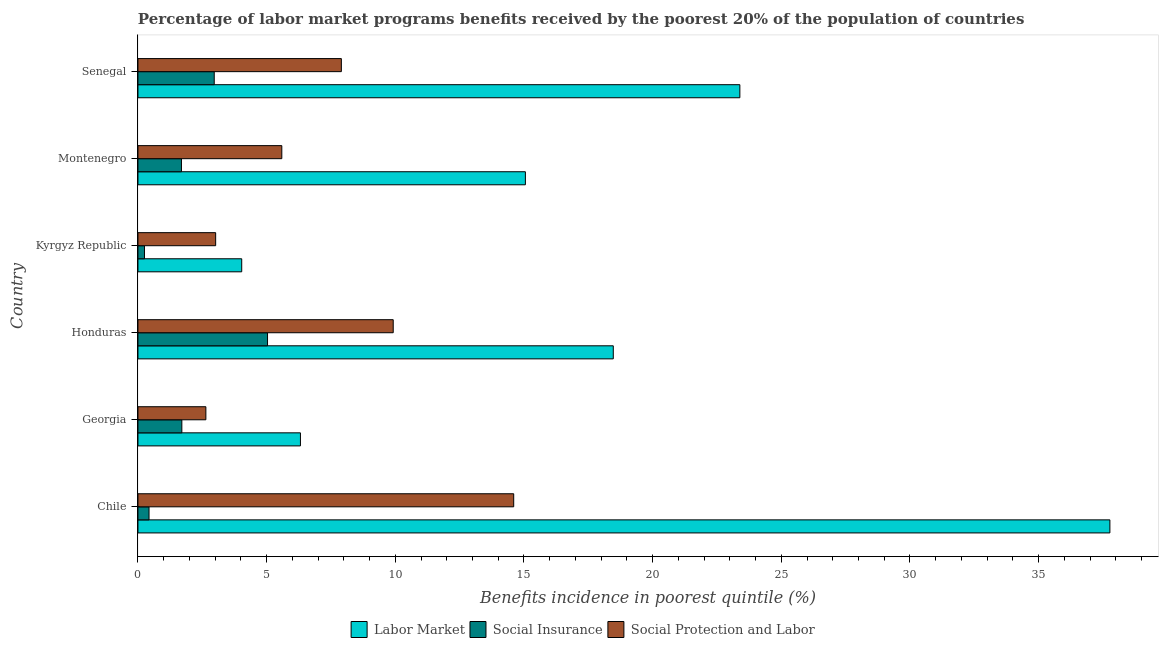How many groups of bars are there?
Provide a short and direct response. 6. Are the number of bars on each tick of the Y-axis equal?
Provide a succinct answer. Yes. What is the label of the 4th group of bars from the top?
Provide a short and direct response. Honduras. In how many cases, is the number of bars for a given country not equal to the number of legend labels?
Your answer should be compact. 0. What is the percentage of benefits received due to social protection programs in Montenegro?
Your response must be concise. 5.59. Across all countries, what is the maximum percentage of benefits received due to social protection programs?
Provide a succinct answer. 14.6. Across all countries, what is the minimum percentage of benefits received due to labor market programs?
Offer a very short reply. 4.03. In which country was the percentage of benefits received due to labor market programs maximum?
Your response must be concise. Chile. In which country was the percentage of benefits received due to labor market programs minimum?
Your answer should be very brief. Kyrgyz Republic. What is the total percentage of benefits received due to social protection programs in the graph?
Provide a succinct answer. 43.67. What is the difference between the percentage of benefits received due to labor market programs in Georgia and that in Kyrgyz Republic?
Your response must be concise. 2.28. What is the difference between the percentage of benefits received due to social protection programs in Honduras and the percentage of benefits received due to labor market programs in Chile?
Your response must be concise. -27.85. What is the average percentage of benefits received due to social insurance programs per country?
Keep it short and to the point. 2.01. What is the difference between the percentage of benefits received due to social insurance programs and percentage of benefits received due to social protection programs in Chile?
Your response must be concise. -14.17. In how many countries, is the percentage of benefits received due to social insurance programs greater than 14 %?
Provide a short and direct response. 0. What is the ratio of the percentage of benefits received due to labor market programs in Chile to that in Honduras?
Ensure brevity in your answer.  2.04. Is the percentage of benefits received due to labor market programs in Chile less than that in Senegal?
Your response must be concise. No. Is the difference between the percentage of benefits received due to social protection programs in Georgia and Montenegro greater than the difference between the percentage of benefits received due to social insurance programs in Georgia and Montenegro?
Make the answer very short. No. What is the difference between the highest and the second highest percentage of benefits received due to social insurance programs?
Offer a terse response. 2.07. What is the difference between the highest and the lowest percentage of benefits received due to social insurance programs?
Offer a very short reply. 4.78. In how many countries, is the percentage of benefits received due to social protection programs greater than the average percentage of benefits received due to social protection programs taken over all countries?
Make the answer very short. 3. What does the 3rd bar from the top in Montenegro represents?
Offer a very short reply. Labor Market. What does the 3rd bar from the bottom in Montenegro represents?
Provide a short and direct response. Social Protection and Labor. How many bars are there?
Your answer should be very brief. 18. Are all the bars in the graph horizontal?
Your answer should be very brief. Yes. Does the graph contain grids?
Provide a short and direct response. No. Where does the legend appear in the graph?
Make the answer very short. Bottom center. How many legend labels are there?
Your answer should be compact. 3. What is the title of the graph?
Your answer should be compact. Percentage of labor market programs benefits received by the poorest 20% of the population of countries. What is the label or title of the X-axis?
Provide a succinct answer. Benefits incidence in poorest quintile (%). What is the Benefits incidence in poorest quintile (%) of Labor Market in Chile?
Provide a succinct answer. 37.77. What is the Benefits incidence in poorest quintile (%) in Social Insurance in Chile?
Your answer should be compact. 0.43. What is the Benefits incidence in poorest quintile (%) of Social Protection and Labor in Chile?
Ensure brevity in your answer.  14.6. What is the Benefits incidence in poorest quintile (%) of Labor Market in Georgia?
Your answer should be very brief. 6.31. What is the Benefits incidence in poorest quintile (%) of Social Insurance in Georgia?
Provide a succinct answer. 1.71. What is the Benefits incidence in poorest quintile (%) in Social Protection and Labor in Georgia?
Offer a terse response. 2.64. What is the Benefits incidence in poorest quintile (%) of Labor Market in Honduras?
Provide a short and direct response. 18.47. What is the Benefits incidence in poorest quintile (%) of Social Insurance in Honduras?
Provide a succinct answer. 5.04. What is the Benefits incidence in poorest quintile (%) of Social Protection and Labor in Honduras?
Your response must be concise. 9.92. What is the Benefits incidence in poorest quintile (%) of Labor Market in Kyrgyz Republic?
Provide a succinct answer. 4.03. What is the Benefits incidence in poorest quintile (%) in Social Insurance in Kyrgyz Republic?
Offer a very short reply. 0.25. What is the Benefits incidence in poorest quintile (%) in Social Protection and Labor in Kyrgyz Republic?
Keep it short and to the point. 3.02. What is the Benefits incidence in poorest quintile (%) of Labor Market in Montenegro?
Your answer should be very brief. 15.05. What is the Benefits incidence in poorest quintile (%) in Social Insurance in Montenegro?
Keep it short and to the point. 1.69. What is the Benefits incidence in poorest quintile (%) in Social Protection and Labor in Montenegro?
Offer a terse response. 5.59. What is the Benefits incidence in poorest quintile (%) in Labor Market in Senegal?
Ensure brevity in your answer.  23.39. What is the Benefits incidence in poorest quintile (%) of Social Insurance in Senegal?
Give a very brief answer. 2.96. What is the Benefits incidence in poorest quintile (%) of Social Protection and Labor in Senegal?
Offer a terse response. 7.9. Across all countries, what is the maximum Benefits incidence in poorest quintile (%) of Labor Market?
Provide a short and direct response. 37.77. Across all countries, what is the maximum Benefits incidence in poorest quintile (%) of Social Insurance?
Offer a very short reply. 5.04. Across all countries, what is the maximum Benefits incidence in poorest quintile (%) of Social Protection and Labor?
Ensure brevity in your answer.  14.6. Across all countries, what is the minimum Benefits incidence in poorest quintile (%) of Labor Market?
Provide a succinct answer. 4.03. Across all countries, what is the minimum Benefits incidence in poorest quintile (%) of Social Insurance?
Offer a very short reply. 0.25. Across all countries, what is the minimum Benefits incidence in poorest quintile (%) in Social Protection and Labor?
Your response must be concise. 2.64. What is the total Benefits incidence in poorest quintile (%) of Labor Market in the graph?
Provide a short and direct response. 105.03. What is the total Benefits incidence in poorest quintile (%) of Social Insurance in the graph?
Offer a terse response. 12.08. What is the total Benefits incidence in poorest quintile (%) in Social Protection and Labor in the graph?
Provide a succinct answer. 43.67. What is the difference between the Benefits incidence in poorest quintile (%) of Labor Market in Chile and that in Georgia?
Provide a short and direct response. 31.45. What is the difference between the Benefits incidence in poorest quintile (%) in Social Insurance in Chile and that in Georgia?
Give a very brief answer. -1.27. What is the difference between the Benefits incidence in poorest quintile (%) of Social Protection and Labor in Chile and that in Georgia?
Make the answer very short. 11.96. What is the difference between the Benefits incidence in poorest quintile (%) in Labor Market in Chile and that in Honduras?
Your response must be concise. 19.3. What is the difference between the Benefits incidence in poorest quintile (%) of Social Insurance in Chile and that in Honduras?
Offer a terse response. -4.6. What is the difference between the Benefits incidence in poorest quintile (%) of Social Protection and Labor in Chile and that in Honduras?
Ensure brevity in your answer.  4.68. What is the difference between the Benefits incidence in poorest quintile (%) of Labor Market in Chile and that in Kyrgyz Republic?
Your answer should be very brief. 33.74. What is the difference between the Benefits incidence in poorest quintile (%) of Social Insurance in Chile and that in Kyrgyz Republic?
Provide a succinct answer. 0.18. What is the difference between the Benefits incidence in poorest quintile (%) of Social Protection and Labor in Chile and that in Kyrgyz Republic?
Keep it short and to the point. 11.58. What is the difference between the Benefits incidence in poorest quintile (%) in Labor Market in Chile and that in Montenegro?
Offer a very short reply. 22.71. What is the difference between the Benefits incidence in poorest quintile (%) in Social Insurance in Chile and that in Montenegro?
Provide a succinct answer. -1.26. What is the difference between the Benefits incidence in poorest quintile (%) in Social Protection and Labor in Chile and that in Montenegro?
Offer a very short reply. 9.01. What is the difference between the Benefits incidence in poorest quintile (%) in Labor Market in Chile and that in Senegal?
Offer a terse response. 14.38. What is the difference between the Benefits incidence in poorest quintile (%) of Social Insurance in Chile and that in Senegal?
Give a very brief answer. -2.53. What is the difference between the Benefits incidence in poorest quintile (%) of Social Protection and Labor in Chile and that in Senegal?
Provide a succinct answer. 6.7. What is the difference between the Benefits incidence in poorest quintile (%) in Labor Market in Georgia and that in Honduras?
Provide a succinct answer. -12.16. What is the difference between the Benefits incidence in poorest quintile (%) of Social Insurance in Georgia and that in Honduras?
Ensure brevity in your answer.  -3.33. What is the difference between the Benefits incidence in poorest quintile (%) in Social Protection and Labor in Georgia and that in Honduras?
Give a very brief answer. -7.28. What is the difference between the Benefits incidence in poorest quintile (%) of Labor Market in Georgia and that in Kyrgyz Republic?
Offer a very short reply. 2.28. What is the difference between the Benefits incidence in poorest quintile (%) in Social Insurance in Georgia and that in Kyrgyz Republic?
Provide a short and direct response. 1.45. What is the difference between the Benefits incidence in poorest quintile (%) in Social Protection and Labor in Georgia and that in Kyrgyz Republic?
Provide a short and direct response. -0.38. What is the difference between the Benefits incidence in poorest quintile (%) in Labor Market in Georgia and that in Montenegro?
Give a very brief answer. -8.74. What is the difference between the Benefits incidence in poorest quintile (%) of Social Insurance in Georgia and that in Montenegro?
Offer a very short reply. 0.02. What is the difference between the Benefits incidence in poorest quintile (%) in Social Protection and Labor in Georgia and that in Montenegro?
Provide a short and direct response. -2.95. What is the difference between the Benefits incidence in poorest quintile (%) of Labor Market in Georgia and that in Senegal?
Ensure brevity in your answer.  -17.07. What is the difference between the Benefits incidence in poorest quintile (%) in Social Insurance in Georgia and that in Senegal?
Your answer should be very brief. -1.26. What is the difference between the Benefits incidence in poorest quintile (%) of Social Protection and Labor in Georgia and that in Senegal?
Provide a short and direct response. -5.26. What is the difference between the Benefits incidence in poorest quintile (%) of Labor Market in Honduras and that in Kyrgyz Republic?
Make the answer very short. 14.44. What is the difference between the Benefits incidence in poorest quintile (%) of Social Insurance in Honduras and that in Kyrgyz Republic?
Provide a short and direct response. 4.78. What is the difference between the Benefits incidence in poorest quintile (%) in Social Protection and Labor in Honduras and that in Kyrgyz Republic?
Your response must be concise. 6.9. What is the difference between the Benefits incidence in poorest quintile (%) in Labor Market in Honduras and that in Montenegro?
Your response must be concise. 3.42. What is the difference between the Benefits incidence in poorest quintile (%) of Social Insurance in Honduras and that in Montenegro?
Offer a very short reply. 3.35. What is the difference between the Benefits incidence in poorest quintile (%) in Social Protection and Labor in Honduras and that in Montenegro?
Make the answer very short. 4.33. What is the difference between the Benefits incidence in poorest quintile (%) of Labor Market in Honduras and that in Senegal?
Make the answer very short. -4.92. What is the difference between the Benefits incidence in poorest quintile (%) of Social Insurance in Honduras and that in Senegal?
Provide a succinct answer. 2.07. What is the difference between the Benefits incidence in poorest quintile (%) of Social Protection and Labor in Honduras and that in Senegal?
Your answer should be compact. 2.02. What is the difference between the Benefits incidence in poorest quintile (%) of Labor Market in Kyrgyz Republic and that in Montenegro?
Give a very brief answer. -11.02. What is the difference between the Benefits incidence in poorest quintile (%) of Social Insurance in Kyrgyz Republic and that in Montenegro?
Your answer should be very brief. -1.44. What is the difference between the Benefits incidence in poorest quintile (%) in Social Protection and Labor in Kyrgyz Republic and that in Montenegro?
Your answer should be compact. -2.57. What is the difference between the Benefits incidence in poorest quintile (%) of Labor Market in Kyrgyz Republic and that in Senegal?
Your answer should be very brief. -19.36. What is the difference between the Benefits incidence in poorest quintile (%) in Social Insurance in Kyrgyz Republic and that in Senegal?
Give a very brief answer. -2.71. What is the difference between the Benefits incidence in poorest quintile (%) in Social Protection and Labor in Kyrgyz Republic and that in Senegal?
Make the answer very short. -4.88. What is the difference between the Benefits incidence in poorest quintile (%) of Labor Market in Montenegro and that in Senegal?
Keep it short and to the point. -8.33. What is the difference between the Benefits incidence in poorest quintile (%) in Social Insurance in Montenegro and that in Senegal?
Make the answer very short. -1.27. What is the difference between the Benefits incidence in poorest quintile (%) in Social Protection and Labor in Montenegro and that in Senegal?
Your answer should be compact. -2.31. What is the difference between the Benefits incidence in poorest quintile (%) of Labor Market in Chile and the Benefits incidence in poorest quintile (%) of Social Insurance in Georgia?
Your response must be concise. 36.06. What is the difference between the Benefits incidence in poorest quintile (%) in Labor Market in Chile and the Benefits incidence in poorest quintile (%) in Social Protection and Labor in Georgia?
Your answer should be compact. 35.13. What is the difference between the Benefits incidence in poorest quintile (%) of Social Insurance in Chile and the Benefits incidence in poorest quintile (%) of Social Protection and Labor in Georgia?
Your answer should be very brief. -2.21. What is the difference between the Benefits incidence in poorest quintile (%) in Labor Market in Chile and the Benefits incidence in poorest quintile (%) in Social Insurance in Honduras?
Your response must be concise. 32.73. What is the difference between the Benefits incidence in poorest quintile (%) of Labor Market in Chile and the Benefits incidence in poorest quintile (%) of Social Protection and Labor in Honduras?
Your response must be concise. 27.85. What is the difference between the Benefits incidence in poorest quintile (%) of Social Insurance in Chile and the Benefits incidence in poorest quintile (%) of Social Protection and Labor in Honduras?
Offer a terse response. -9.49. What is the difference between the Benefits incidence in poorest quintile (%) of Labor Market in Chile and the Benefits incidence in poorest quintile (%) of Social Insurance in Kyrgyz Republic?
Make the answer very short. 37.51. What is the difference between the Benefits incidence in poorest quintile (%) of Labor Market in Chile and the Benefits incidence in poorest quintile (%) of Social Protection and Labor in Kyrgyz Republic?
Keep it short and to the point. 34.75. What is the difference between the Benefits incidence in poorest quintile (%) in Social Insurance in Chile and the Benefits incidence in poorest quintile (%) in Social Protection and Labor in Kyrgyz Republic?
Your answer should be compact. -2.59. What is the difference between the Benefits incidence in poorest quintile (%) in Labor Market in Chile and the Benefits incidence in poorest quintile (%) in Social Insurance in Montenegro?
Your response must be concise. 36.08. What is the difference between the Benefits incidence in poorest quintile (%) of Labor Market in Chile and the Benefits incidence in poorest quintile (%) of Social Protection and Labor in Montenegro?
Your response must be concise. 32.18. What is the difference between the Benefits incidence in poorest quintile (%) in Social Insurance in Chile and the Benefits incidence in poorest quintile (%) in Social Protection and Labor in Montenegro?
Make the answer very short. -5.16. What is the difference between the Benefits incidence in poorest quintile (%) in Labor Market in Chile and the Benefits incidence in poorest quintile (%) in Social Insurance in Senegal?
Provide a succinct answer. 34.8. What is the difference between the Benefits incidence in poorest quintile (%) in Labor Market in Chile and the Benefits incidence in poorest quintile (%) in Social Protection and Labor in Senegal?
Provide a short and direct response. 29.86. What is the difference between the Benefits incidence in poorest quintile (%) in Social Insurance in Chile and the Benefits incidence in poorest quintile (%) in Social Protection and Labor in Senegal?
Your response must be concise. -7.47. What is the difference between the Benefits incidence in poorest quintile (%) of Labor Market in Georgia and the Benefits incidence in poorest quintile (%) of Social Insurance in Honduras?
Give a very brief answer. 1.28. What is the difference between the Benefits incidence in poorest quintile (%) in Labor Market in Georgia and the Benefits incidence in poorest quintile (%) in Social Protection and Labor in Honduras?
Ensure brevity in your answer.  -3.61. What is the difference between the Benefits incidence in poorest quintile (%) of Social Insurance in Georgia and the Benefits incidence in poorest quintile (%) of Social Protection and Labor in Honduras?
Provide a succinct answer. -8.21. What is the difference between the Benefits incidence in poorest quintile (%) of Labor Market in Georgia and the Benefits incidence in poorest quintile (%) of Social Insurance in Kyrgyz Republic?
Keep it short and to the point. 6.06. What is the difference between the Benefits incidence in poorest quintile (%) in Labor Market in Georgia and the Benefits incidence in poorest quintile (%) in Social Protection and Labor in Kyrgyz Republic?
Provide a short and direct response. 3.29. What is the difference between the Benefits incidence in poorest quintile (%) of Social Insurance in Georgia and the Benefits incidence in poorest quintile (%) of Social Protection and Labor in Kyrgyz Republic?
Provide a succinct answer. -1.31. What is the difference between the Benefits incidence in poorest quintile (%) of Labor Market in Georgia and the Benefits incidence in poorest quintile (%) of Social Insurance in Montenegro?
Your answer should be very brief. 4.62. What is the difference between the Benefits incidence in poorest quintile (%) in Labor Market in Georgia and the Benefits incidence in poorest quintile (%) in Social Protection and Labor in Montenegro?
Your answer should be compact. 0.72. What is the difference between the Benefits incidence in poorest quintile (%) of Social Insurance in Georgia and the Benefits incidence in poorest quintile (%) of Social Protection and Labor in Montenegro?
Offer a terse response. -3.88. What is the difference between the Benefits incidence in poorest quintile (%) of Labor Market in Georgia and the Benefits incidence in poorest quintile (%) of Social Insurance in Senegal?
Make the answer very short. 3.35. What is the difference between the Benefits incidence in poorest quintile (%) of Labor Market in Georgia and the Benefits incidence in poorest quintile (%) of Social Protection and Labor in Senegal?
Your answer should be very brief. -1.59. What is the difference between the Benefits incidence in poorest quintile (%) of Social Insurance in Georgia and the Benefits incidence in poorest quintile (%) of Social Protection and Labor in Senegal?
Provide a succinct answer. -6.2. What is the difference between the Benefits incidence in poorest quintile (%) in Labor Market in Honduras and the Benefits incidence in poorest quintile (%) in Social Insurance in Kyrgyz Republic?
Your answer should be very brief. 18.22. What is the difference between the Benefits incidence in poorest quintile (%) of Labor Market in Honduras and the Benefits incidence in poorest quintile (%) of Social Protection and Labor in Kyrgyz Republic?
Give a very brief answer. 15.45. What is the difference between the Benefits incidence in poorest quintile (%) of Social Insurance in Honduras and the Benefits incidence in poorest quintile (%) of Social Protection and Labor in Kyrgyz Republic?
Give a very brief answer. 2.02. What is the difference between the Benefits incidence in poorest quintile (%) in Labor Market in Honduras and the Benefits incidence in poorest quintile (%) in Social Insurance in Montenegro?
Ensure brevity in your answer.  16.78. What is the difference between the Benefits incidence in poorest quintile (%) in Labor Market in Honduras and the Benefits incidence in poorest quintile (%) in Social Protection and Labor in Montenegro?
Your response must be concise. 12.88. What is the difference between the Benefits incidence in poorest quintile (%) of Social Insurance in Honduras and the Benefits incidence in poorest quintile (%) of Social Protection and Labor in Montenegro?
Give a very brief answer. -0.55. What is the difference between the Benefits incidence in poorest quintile (%) in Labor Market in Honduras and the Benefits incidence in poorest quintile (%) in Social Insurance in Senegal?
Your answer should be compact. 15.51. What is the difference between the Benefits incidence in poorest quintile (%) in Labor Market in Honduras and the Benefits incidence in poorest quintile (%) in Social Protection and Labor in Senegal?
Your answer should be very brief. 10.57. What is the difference between the Benefits incidence in poorest quintile (%) in Social Insurance in Honduras and the Benefits incidence in poorest quintile (%) in Social Protection and Labor in Senegal?
Provide a succinct answer. -2.87. What is the difference between the Benefits incidence in poorest quintile (%) of Labor Market in Kyrgyz Republic and the Benefits incidence in poorest quintile (%) of Social Insurance in Montenegro?
Offer a very short reply. 2.34. What is the difference between the Benefits incidence in poorest quintile (%) of Labor Market in Kyrgyz Republic and the Benefits incidence in poorest quintile (%) of Social Protection and Labor in Montenegro?
Your response must be concise. -1.56. What is the difference between the Benefits incidence in poorest quintile (%) in Social Insurance in Kyrgyz Republic and the Benefits incidence in poorest quintile (%) in Social Protection and Labor in Montenegro?
Provide a succinct answer. -5.34. What is the difference between the Benefits incidence in poorest quintile (%) in Labor Market in Kyrgyz Republic and the Benefits incidence in poorest quintile (%) in Social Insurance in Senegal?
Ensure brevity in your answer.  1.07. What is the difference between the Benefits incidence in poorest quintile (%) in Labor Market in Kyrgyz Republic and the Benefits incidence in poorest quintile (%) in Social Protection and Labor in Senegal?
Offer a terse response. -3.87. What is the difference between the Benefits incidence in poorest quintile (%) of Social Insurance in Kyrgyz Republic and the Benefits incidence in poorest quintile (%) of Social Protection and Labor in Senegal?
Provide a short and direct response. -7.65. What is the difference between the Benefits incidence in poorest quintile (%) in Labor Market in Montenegro and the Benefits incidence in poorest quintile (%) in Social Insurance in Senegal?
Offer a very short reply. 12.09. What is the difference between the Benefits incidence in poorest quintile (%) in Labor Market in Montenegro and the Benefits incidence in poorest quintile (%) in Social Protection and Labor in Senegal?
Keep it short and to the point. 7.15. What is the difference between the Benefits incidence in poorest quintile (%) of Social Insurance in Montenegro and the Benefits incidence in poorest quintile (%) of Social Protection and Labor in Senegal?
Ensure brevity in your answer.  -6.21. What is the average Benefits incidence in poorest quintile (%) in Labor Market per country?
Offer a very short reply. 17.5. What is the average Benefits incidence in poorest quintile (%) in Social Insurance per country?
Make the answer very short. 2.01. What is the average Benefits incidence in poorest quintile (%) in Social Protection and Labor per country?
Offer a very short reply. 7.28. What is the difference between the Benefits incidence in poorest quintile (%) of Labor Market and Benefits incidence in poorest quintile (%) of Social Insurance in Chile?
Make the answer very short. 37.34. What is the difference between the Benefits incidence in poorest quintile (%) of Labor Market and Benefits incidence in poorest quintile (%) of Social Protection and Labor in Chile?
Give a very brief answer. 23.17. What is the difference between the Benefits incidence in poorest quintile (%) of Social Insurance and Benefits incidence in poorest quintile (%) of Social Protection and Labor in Chile?
Offer a very short reply. -14.17. What is the difference between the Benefits incidence in poorest quintile (%) in Labor Market and Benefits incidence in poorest quintile (%) in Social Insurance in Georgia?
Keep it short and to the point. 4.61. What is the difference between the Benefits incidence in poorest quintile (%) in Labor Market and Benefits incidence in poorest quintile (%) in Social Protection and Labor in Georgia?
Give a very brief answer. 3.67. What is the difference between the Benefits incidence in poorest quintile (%) of Social Insurance and Benefits incidence in poorest quintile (%) of Social Protection and Labor in Georgia?
Your answer should be very brief. -0.93. What is the difference between the Benefits incidence in poorest quintile (%) in Labor Market and Benefits incidence in poorest quintile (%) in Social Insurance in Honduras?
Offer a very short reply. 13.44. What is the difference between the Benefits incidence in poorest quintile (%) in Labor Market and Benefits incidence in poorest quintile (%) in Social Protection and Labor in Honduras?
Keep it short and to the point. 8.55. What is the difference between the Benefits incidence in poorest quintile (%) in Social Insurance and Benefits incidence in poorest quintile (%) in Social Protection and Labor in Honduras?
Offer a terse response. -4.88. What is the difference between the Benefits incidence in poorest quintile (%) in Labor Market and Benefits incidence in poorest quintile (%) in Social Insurance in Kyrgyz Republic?
Offer a terse response. 3.78. What is the difference between the Benefits incidence in poorest quintile (%) in Labor Market and Benefits incidence in poorest quintile (%) in Social Protection and Labor in Kyrgyz Republic?
Provide a short and direct response. 1.01. What is the difference between the Benefits incidence in poorest quintile (%) of Social Insurance and Benefits incidence in poorest quintile (%) of Social Protection and Labor in Kyrgyz Republic?
Keep it short and to the point. -2.77. What is the difference between the Benefits incidence in poorest quintile (%) of Labor Market and Benefits incidence in poorest quintile (%) of Social Insurance in Montenegro?
Offer a very short reply. 13.36. What is the difference between the Benefits incidence in poorest quintile (%) of Labor Market and Benefits incidence in poorest quintile (%) of Social Protection and Labor in Montenegro?
Offer a very short reply. 9.46. What is the difference between the Benefits incidence in poorest quintile (%) in Social Insurance and Benefits incidence in poorest quintile (%) in Social Protection and Labor in Montenegro?
Offer a very short reply. -3.9. What is the difference between the Benefits incidence in poorest quintile (%) in Labor Market and Benefits incidence in poorest quintile (%) in Social Insurance in Senegal?
Offer a very short reply. 20.43. What is the difference between the Benefits incidence in poorest quintile (%) in Labor Market and Benefits incidence in poorest quintile (%) in Social Protection and Labor in Senegal?
Offer a terse response. 15.48. What is the difference between the Benefits incidence in poorest quintile (%) in Social Insurance and Benefits incidence in poorest quintile (%) in Social Protection and Labor in Senegal?
Make the answer very short. -4.94. What is the ratio of the Benefits incidence in poorest quintile (%) in Labor Market in Chile to that in Georgia?
Your response must be concise. 5.98. What is the ratio of the Benefits incidence in poorest quintile (%) in Social Insurance in Chile to that in Georgia?
Your answer should be compact. 0.25. What is the ratio of the Benefits incidence in poorest quintile (%) of Social Protection and Labor in Chile to that in Georgia?
Your answer should be compact. 5.53. What is the ratio of the Benefits incidence in poorest quintile (%) in Labor Market in Chile to that in Honduras?
Your answer should be compact. 2.04. What is the ratio of the Benefits incidence in poorest quintile (%) of Social Insurance in Chile to that in Honduras?
Offer a very short reply. 0.09. What is the ratio of the Benefits incidence in poorest quintile (%) of Social Protection and Labor in Chile to that in Honduras?
Your answer should be compact. 1.47. What is the ratio of the Benefits incidence in poorest quintile (%) in Labor Market in Chile to that in Kyrgyz Republic?
Your answer should be very brief. 9.37. What is the ratio of the Benefits incidence in poorest quintile (%) of Social Insurance in Chile to that in Kyrgyz Republic?
Your answer should be very brief. 1.7. What is the ratio of the Benefits incidence in poorest quintile (%) of Social Protection and Labor in Chile to that in Kyrgyz Republic?
Give a very brief answer. 4.84. What is the ratio of the Benefits incidence in poorest quintile (%) of Labor Market in Chile to that in Montenegro?
Offer a very short reply. 2.51. What is the ratio of the Benefits incidence in poorest quintile (%) of Social Insurance in Chile to that in Montenegro?
Your response must be concise. 0.25. What is the ratio of the Benefits incidence in poorest quintile (%) in Social Protection and Labor in Chile to that in Montenegro?
Ensure brevity in your answer.  2.61. What is the ratio of the Benefits incidence in poorest quintile (%) in Labor Market in Chile to that in Senegal?
Offer a very short reply. 1.61. What is the ratio of the Benefits incidence in poorest quintile (%) of Social Insurance in Chile to that in Senegal?
Offer a very short reply. 0.15. What is the ratio of the Benefits incidence in poorest quintile (%) in Social Protection and Labor in Chile to that in Senegal?
Your answer should be compact. 1.85. What is the ratio of the Benefits incidence in poorest quintile (%) in Labor Market in Georgia to that in Honduras?
Offer a very short reply. 0.34. What is the ratio of the Benefits incidence in poorest quintile (%) in Social Insurance in Georgia to that in Honduras?
Ensure brevity in your answer.  0.34. What is the ratio of the Benefits incidence in poorest quintile (%) in Social Protection and Labor in Georgia to that in Honduras?
Your response must be concise. 0.27. What is the ratio of the Benefits incidence in poorest quintile (%) in Labor Market in Georgia to that in Kyrgyz Republic?
Keep it short and to the point. 1.57. What is the ratio of the Benefits incidence in poorest quintile (%) in Social Insurance in Georgia to that in Kyrgyz Republic?
Ensure brevity in your answer.  6.73. What is the ratio of the Benefits incidence in poorest quintile (%) of Social Protection and Labor in Georgia to that in Kyrgyz Republic?
Give a very brief answer. 0.87. What is the ratio of the Benefits incidence in poorest quintile (%) in Labor Market in Georgia to that in Montenegro?
Your answer should be compact. 0.42. What is the ratio of the Benefits incidence in poorest quintile (%) in Social Insurance in Georgia to that in Montenegro?
Keep it short and to the point. 1.01. What is the ratio of the Benefits incidence in poorest quintile (%) in Social Protection and Labor in Georgia to that in Montenegro?
Your answer should be very brief. 0.47. What is the ratio of the Benefits incidence in poorest quintile (%) in Labor Market in Georgia to that in Senegal?
Keep it short and to the point. 0.27. What is the ratio of the Benefits incidence in poorest quintile (%) in Social Insurance in Georgia to that in Senegal?
Give a very brief answer. 0.58. What is the ratio of the Benefits incidence in poorest quintile (%) in Social Protection and Labor in Georgia to that in Senegal?
Ensure brevity in your answer.  0.33. What is the ratio of the Benefits incidence in poorest quintile (%) in Labor Market in Honduras to that in Kyrgyz Republic?
Ensure brevity in your answer.  4.58. What is the ratio of the Benefits incidence in poorest quintile (%) in Social Insurance in Honduras to that in Kyrgyz Republic?
Offer a terse response. 19.87. What is the ratio of the Benefits incidence in poorest quintile (%) in Social Protection and Labor in Honduras to that in Kyrgyz Republic?
Give a very brief answer. 3.29. What is the ratio of the Benefits incidence in poorest quintile (%) of Labor Market in Honduras to that in Montenegro?
Your answer should be compact. 1.23. What is the ratio of the Benefits incidence in poorest quintile (%) in Social Insurance in Honduras to that in Montenegro?
Keep it short and to the point. 2.98. What is the ratio of the Benefits incidence in poorest quintile (%) of Social Protection and Labor in Honduras to that in Montenegro?
Ensure brevity in your answer.  1.77. What is the ratio of the Benefits incidence in poorest quintile (%) in Labor Market in Honduras to that in Senegal?
Offer a very short reply. 0.79. What is the ratio of the Benefits incidence in poorest quintile (%) of Social Insurance in Honduras to that in Senegal?
Make the answer very short. 1.7. What is the ratio of the Benefits incidence in poorest quintile (%) in Social Protection and Labor in Honduras to that in Senegal?
Offer a very short reply. 1.25. What is the ratio of the Benefits incidence in poorest quintile (%) in Labor Market in Kyrgyz Republic to that in Montenegro?
Provide a short and direct response. 0.27. What is the ratio of the Benefits incidence in poorest quintile (%) in Social Insurance in Kyrgyz Republic to that in Montenegro?
Keep it short and to the point. 0.15. What is the ratio of the Benefits incidence in poorest quintile (%) in Social Protection and Labor in Kyrgyz Republic to that in Montenegro?
Provide a short and direct response. 0.54. What is the ratio of the Benefits incidence in poorest quintile (%) of Labor Market in Kyrgyz Republic to that in Senegal?
Provide a short and direct response. 0.17. What is the ratio of the Benefits incidence in poorest quintile (%) of Social Insurance in Kyrgyz Republic to that in Senegal?
Keep it short and to the point. 0.09. What is the ratio of the Benefits incidence in poorest quintile (%) of Social Protection and Labor in Kyrgyz Republic to that in Senegal?
Make the answer very short. 0.38. What is the ratio of the Benefits incidence in poorest quintile (%) of Labor Market in Montenegro to that in Senegal?
Give a very brief answer. 0.64. What is the ratio of the Benefits incidence in poorest quintile (%) of Social Insurance in Montenegro to that in Senegal?
Give a very brief answer. 0.57. What is the ratio of the Benefits incidence in poorest quintile (%) of Social Protection and Labor in Montenegro to that in Senegal?
Your answer should be very brief. 0.71. What is the difference between the highest and the second highest Benefits incidence in poorest quintile (%) in Labor Market?
Provide a succinct answer. 14.38. What is the difference between the highest and the second highest Benefits incidence in poorest quintile (%) in Social Insurance?
Make the answer very short. 2.07. What is the difference between the highest and the second highest Benefits incidence in poorest quintile (%) of Social Protection and Labor?
Your answer should be compact. 4.68. What is the difference between the highest and the lowest Benefits incidence in poorest quintile (%) of Labor Market?
Give a very brief answer. 33.74. What is the difference between the highest and the lowest Benefits incidence in poorest quintile (%) in Social Insurance?
Give a very brief answer. 4.78. What is the difference between the highest and the lowest Benefits incidence in poorest quintile (%) of Social Protection and Labor?
Make the answer very short. 11.96. 